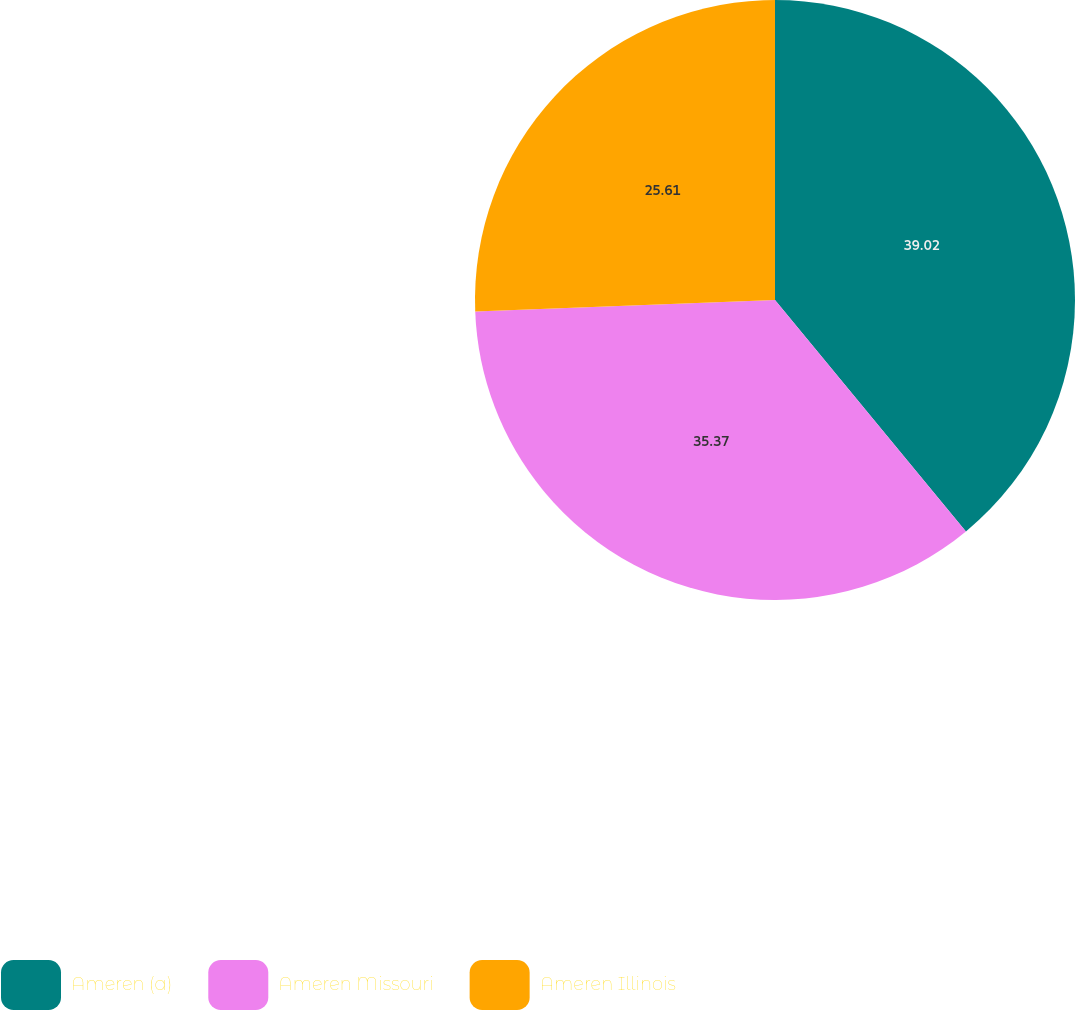Convert chart to OTSL. <chart><loc_0><loc_0><loc_500><loc_500><pie_chart><fcel>Ameren (a)<fcel>Ameren Missouri<fcel>Ameren Illinois<nl><fcel>39.02%<fcel>35.37%<fcel>25.61%<nl></chart> 